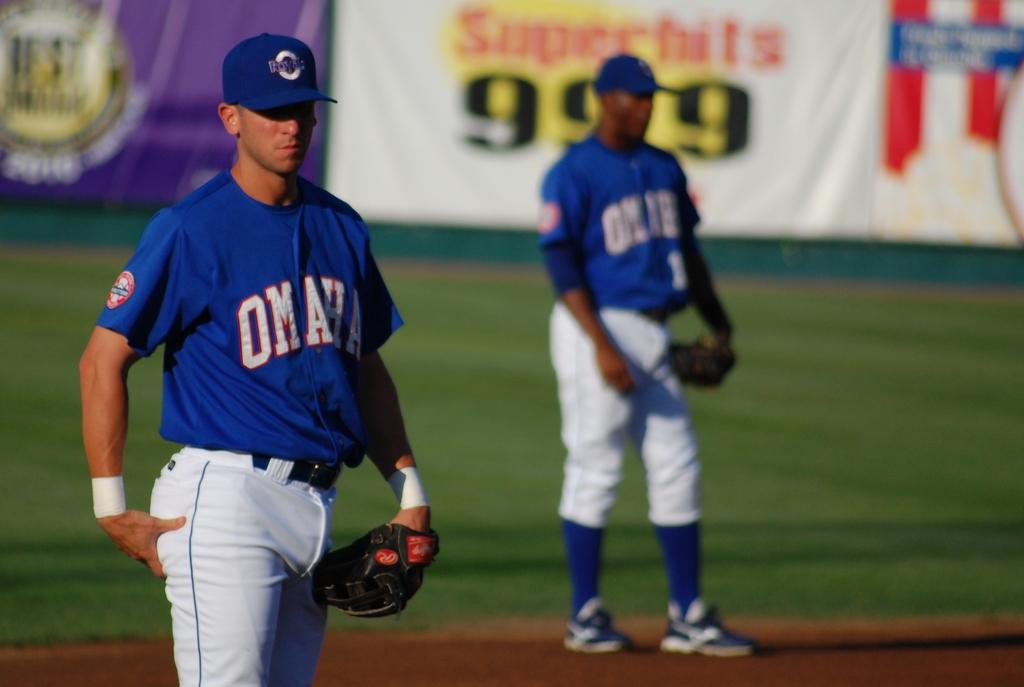Provide a one-sentence caption for the provided image. A baseball player with the word Omaha on his shirt. 